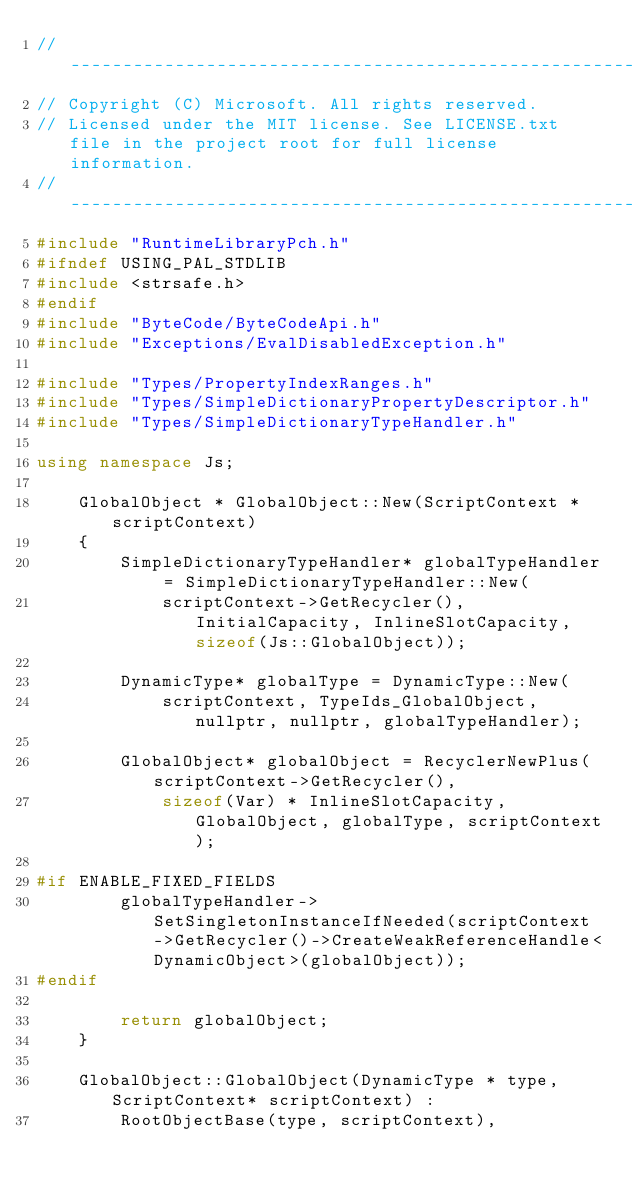Convert code to text. <code><loc_0><loc_0><loc_500><loc_500><_C++_>//-------------------------------------------------------------------------------------------------------
// Copyright (C) Microsoft. All rights reserved.
// Licensed under the MIT license. See LICENSE.txt file in the project root for full license information.
//-------------------------------------------------------------------------------------------------------
#include "RuntimeLibraryPch.h"
#ifndef USING_PAL_STDLIB
#include <strsafe.h>
#endif
#include "ByteCode/ByteCodeApi.h"
#include "Exceptions/EvalDisabledException.h"

#include "Types/PropertyIndexRanges.h"
#include "Types/SimpleDictionaryPropertyDescriptor.h"
#include "Types/SimpleDictionaryTypeHandler.h"

using namespace Js;

    GlobalObject * GlobalObject::New(ScriptContext * scriptContext)
    {
        SimpleDictionaryTypeHandler* globalTypeHandler = SimpleDictionaryTypeHandler::New(
            scriptContext->GetRecycler(), InitialCapacity, InlineSlotCapacity, sizeof(Js::GlobalObject));

        DynamicType* globalType = DynamicType::New(
            scriptContext, TypeIds_GlobalObject, nullptr, nullptr, globalTypeHandler);

        GlobalObject* globalObject = RecyclerNewPlus(scriptContext->GetRecycler(),
            sizeof(Var) * InlineSlotCapacity, GlobalObject, globalType, scriptContext);

#if ENABLE_FIXED_FIELDS
        globalTypeHandler->SetSingletonInstanceIfNeeded(scriptContext->GetRecycler()->CreateWeakReferenceHandle<DynamicObject>(globalObject));
#endif

        return globalObject;
    }

    GlobalObject::GlobalObject(DynamicType * type, ScriptContext* scriptContext) :
        RootObjectBase(type, scriptContext),</code> 